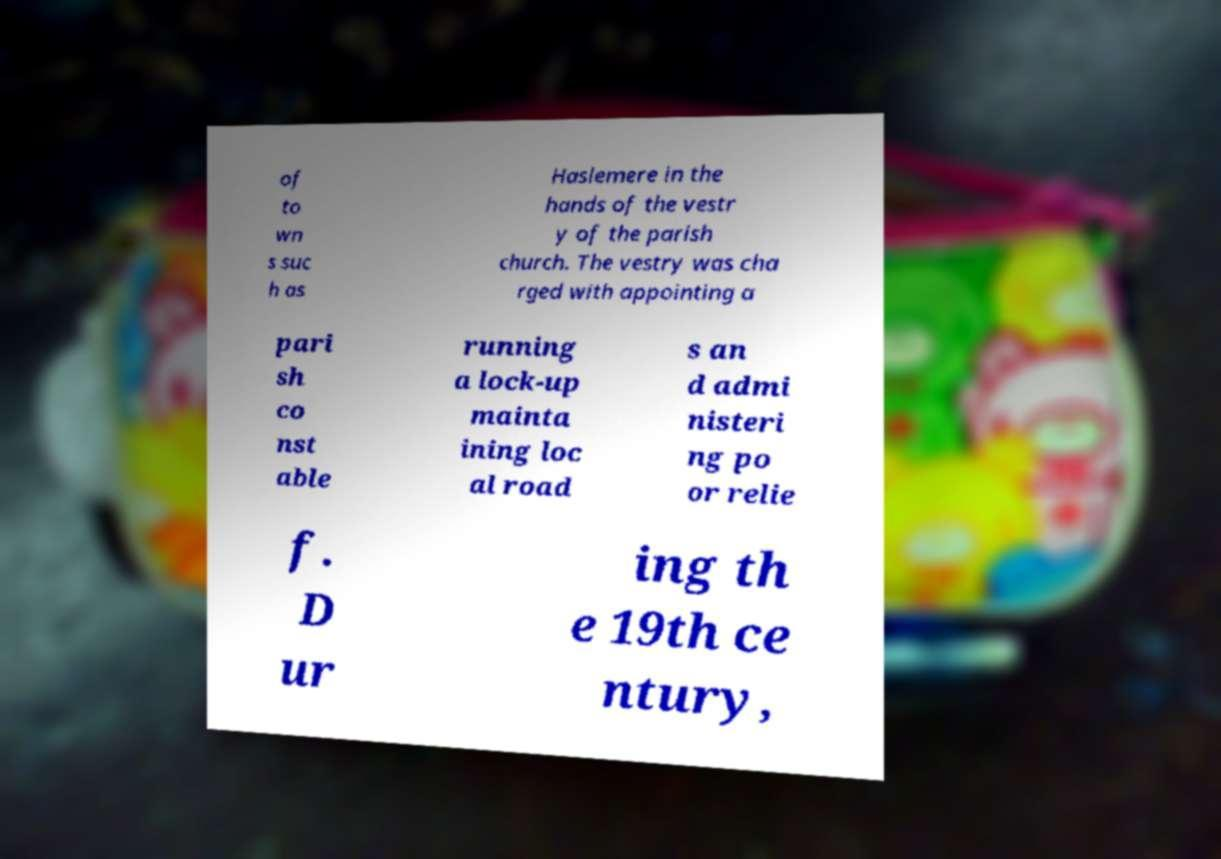What messages or text are displayed in this image? I need them in a readable, typed format. of to wn s suc h as Haslemere in the hands of the vestr y of the parish church. The vestry was cha rged with appointing a pari sh co nst able running a lock-up mainta ining loc al road s an d admi nisteri ng po or relie f. D ur ing th e 19th ce ntury, 